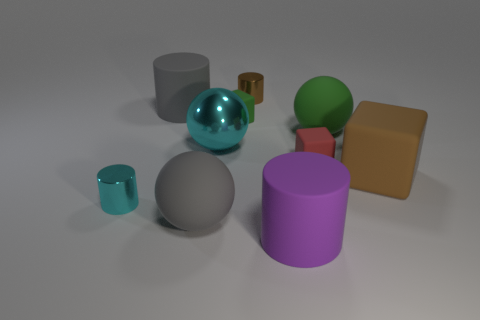Subtract all small rubber cubes. How many cubes are left? 1 Subtract 1 spheres. How many spheres are left? 2 Subtract all purple cylinders. How many cylinders are left? 3 Subtract all blue cylinders. Subtract all cyan balls. How many cylinders are left? 4 Subtract all blocks. How many objects are left? 7 Add 2 large purple things. How many large purple things exist? 3 Subtract 0 blue cylinders. How many objects are left? 10 Subtract all tiny blue metal cubes. Subtract all tiny objects. How many objects are left? 6 Add 7 large matte blocks. How many large matte blocks are left? 8 